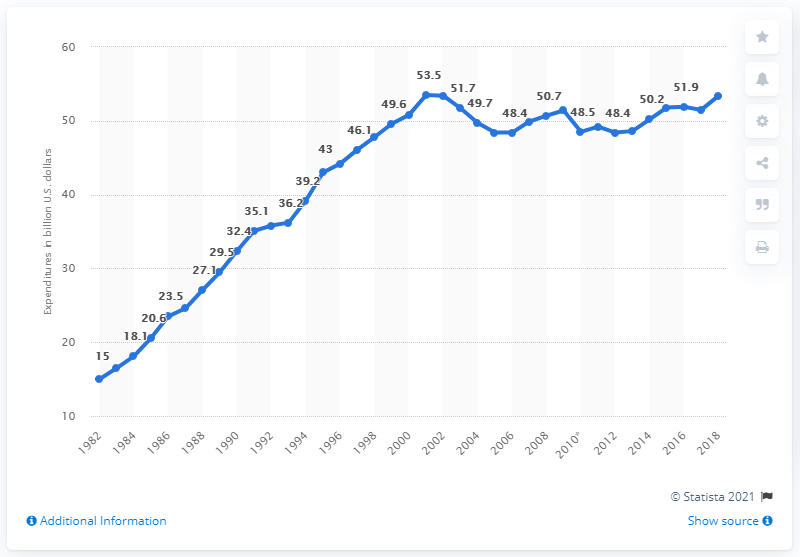Identify some key points in this picture. The total expenditure of state correction institutions in 2018 was 53.38 million. 